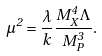Convert formula to latex. <formula><loc_0><loc_0><loc_500><loc_500>\mu ^ { 2 } = \frac { \lambda } { k } \frac { M ^ { 4 } _ { X } \Lambda } { M ^ { 3 } _ { P } } .</formula> 